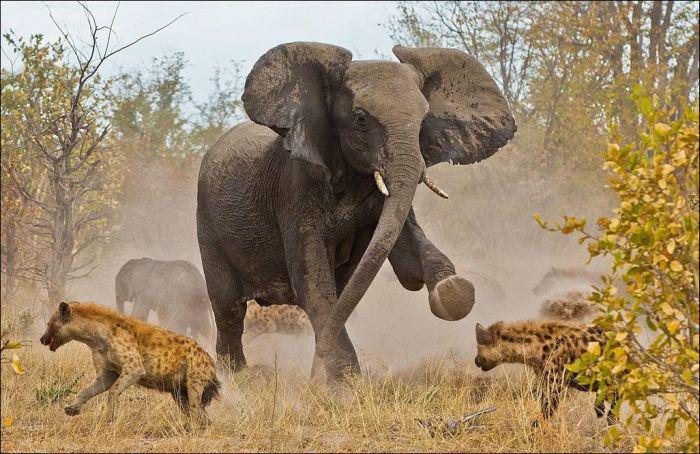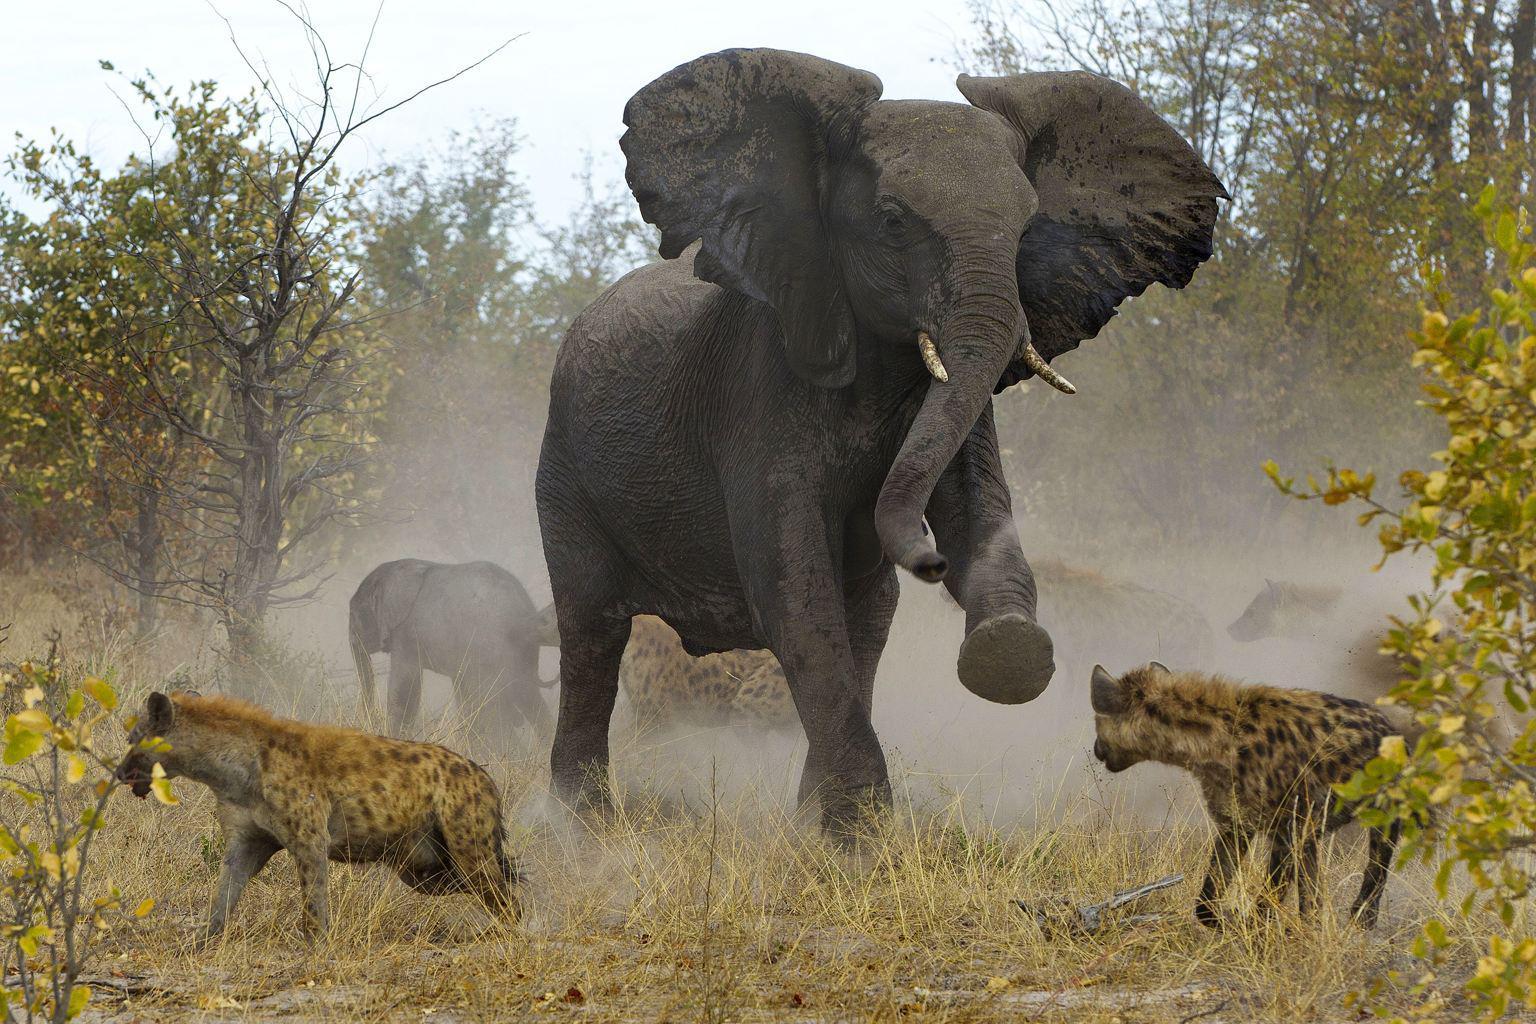The first image is the image on the left, the second image is the image on the right. Examine the images to the left and right. Is the description "Each image shows an elephant in a similar forward charging pose near hyenas." accurate? Answer yes or no. Yes. 